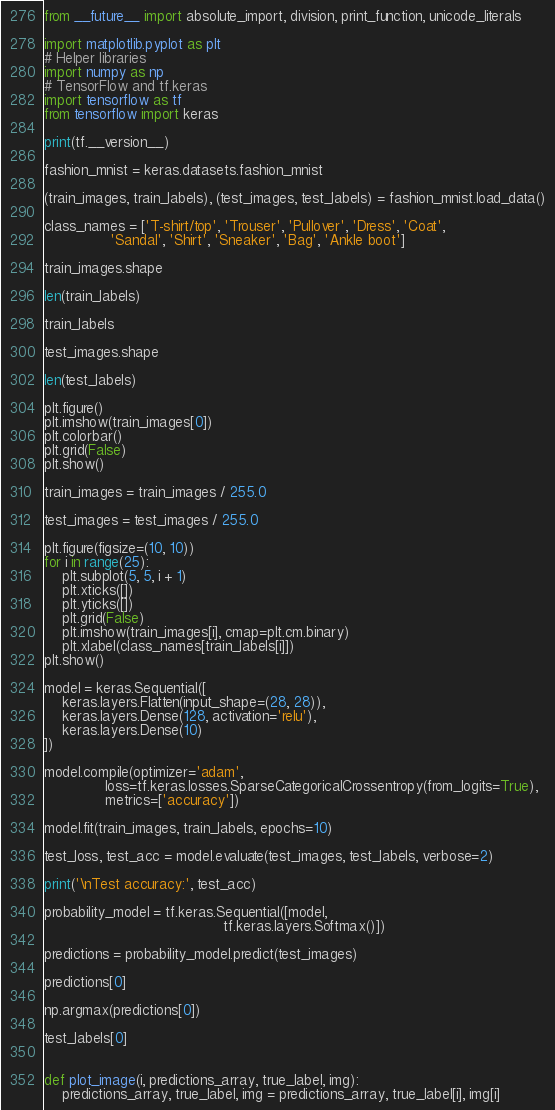<code> <loc_0><loc_0><loc_500><loc_500><_Python_>from __future__ import absolute_import, division, print_function, unicode_literals

import matplotlib.pyplot as plt
# Helper libraries
import numpy as np
# TensorFlow and tf.keras
import tensorflow as tf
from tensorflow import keras

print(tf.__version__)

fashion_mnist = keras.datasets.fashion_mnist

(train_images, train_labels), (test_images, test_labels) = fashion_mnist.load_data()

class_names = ['T-shirt/top', 'Trouser', 'Pullover', 'Dress', 'Coat',
               'Sandal', 'Shirt', 'Sneaker', 'Bag', 'Ankle boot']

train_images.shape

len(train_labels)

train_labels

test_images.shape

len(test_labels)

plt.figure()
plt.imshow(train_images[0])
plt.colorbar()
plt.grid(False)
plt.show()

train_images = train_images / 255.0

test_images = test_images / 255.0

plt.figure(figsize=(10, 10))
for i in range(25):
    plt.subplot(5, 5, i + 1)
    plt.xticks([])
    plt.yticks([])
    plt.grid(False)
    plt.imshow(train_images[i], cmap=plt.cm.binary)
    plt.xlabel(class_names[train_labels[i]])
plt.show()

model = keras.Sequential([
    keras.layers.Flatten(input_shape=(28, 28)),
    keras.layers.Dense(128, activation='relu'),
    keras.layers.Dense(10)
])

model.compile(optimizer='adam',
              loss=tf.keras.losses.SparseCategoricalCrossentropy(from_logits=True),
              metrics=['accuracy'])

model.fit(train_images, train_labels, epochs=10)

test_loss, test_acc = model.evaluate(test_images, test_labels, verbose=2)

print('\nTest accuracy:', test_acc)

probability_model = tf.keras.Sequential([model,
                                         tf.keras.layers.Softmax()])

predictions = probability_model.predict(test_images)

predictions[0]

np.argmax(predictions[0])

test_labels[0]


def plot_image(i, predictions_array, true_label, img):
    predictions_array, true_label, img = predictions_array, true_label[i], img[i]</code> 